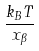<formula> <loc_0><loc_0><loc_500><loc_500>\frac { k _ { B } T } { x _ { \beta } }</formula> 